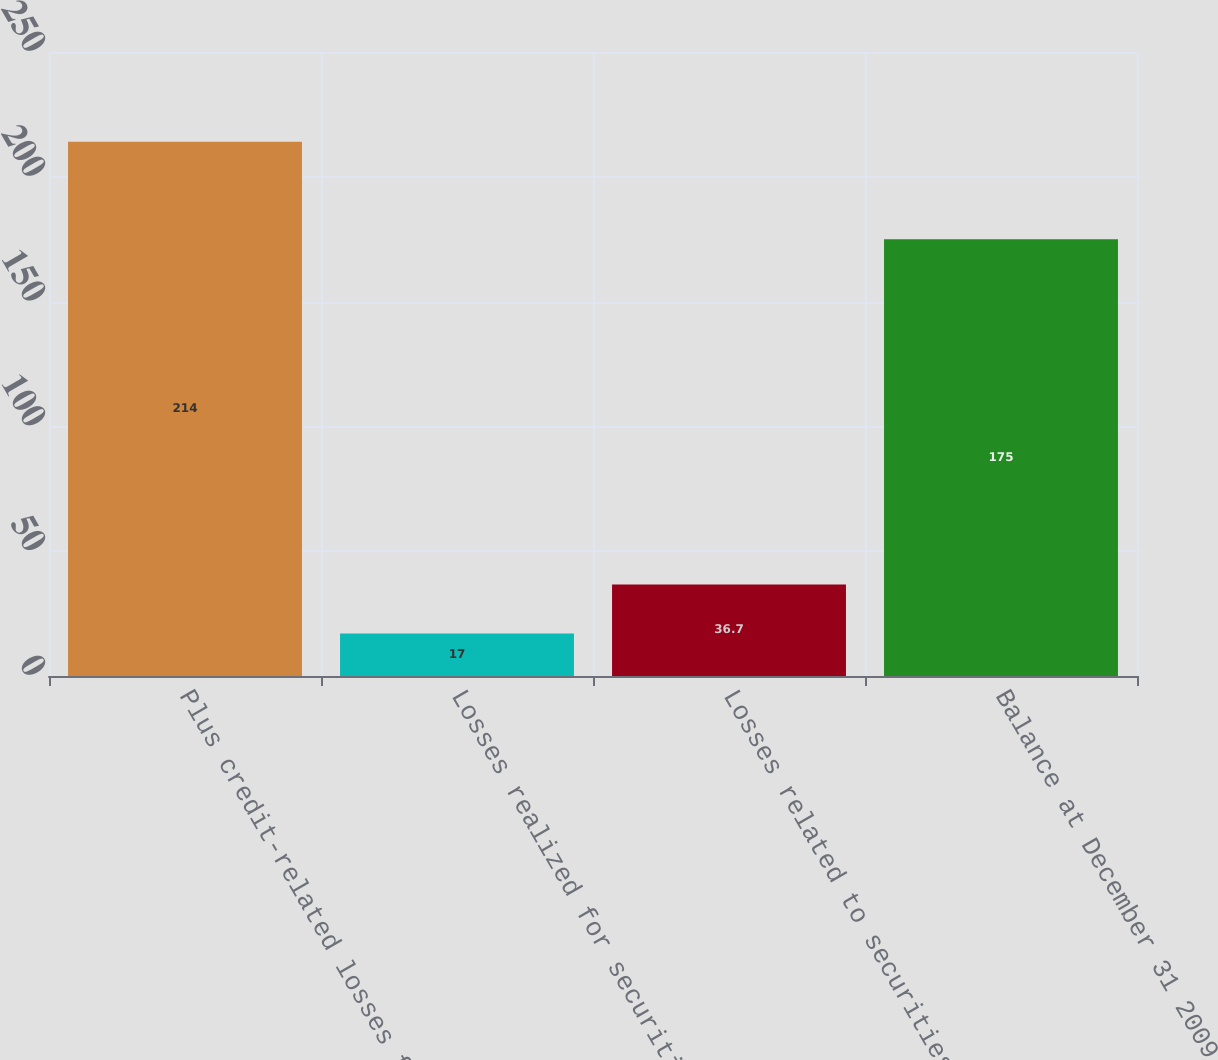Convert chart. <chart><loc_0><loc_0><loc_500><loc_500><bar_chart><fcel>Plus credit-related losses for<fcel>Losses realized for securities<fcel>Losses related to securities<fcel>Balance at December 31 2009<nl><fcel>214<fcel>17<fcel>36.7<fcel>175<nl></chart> 